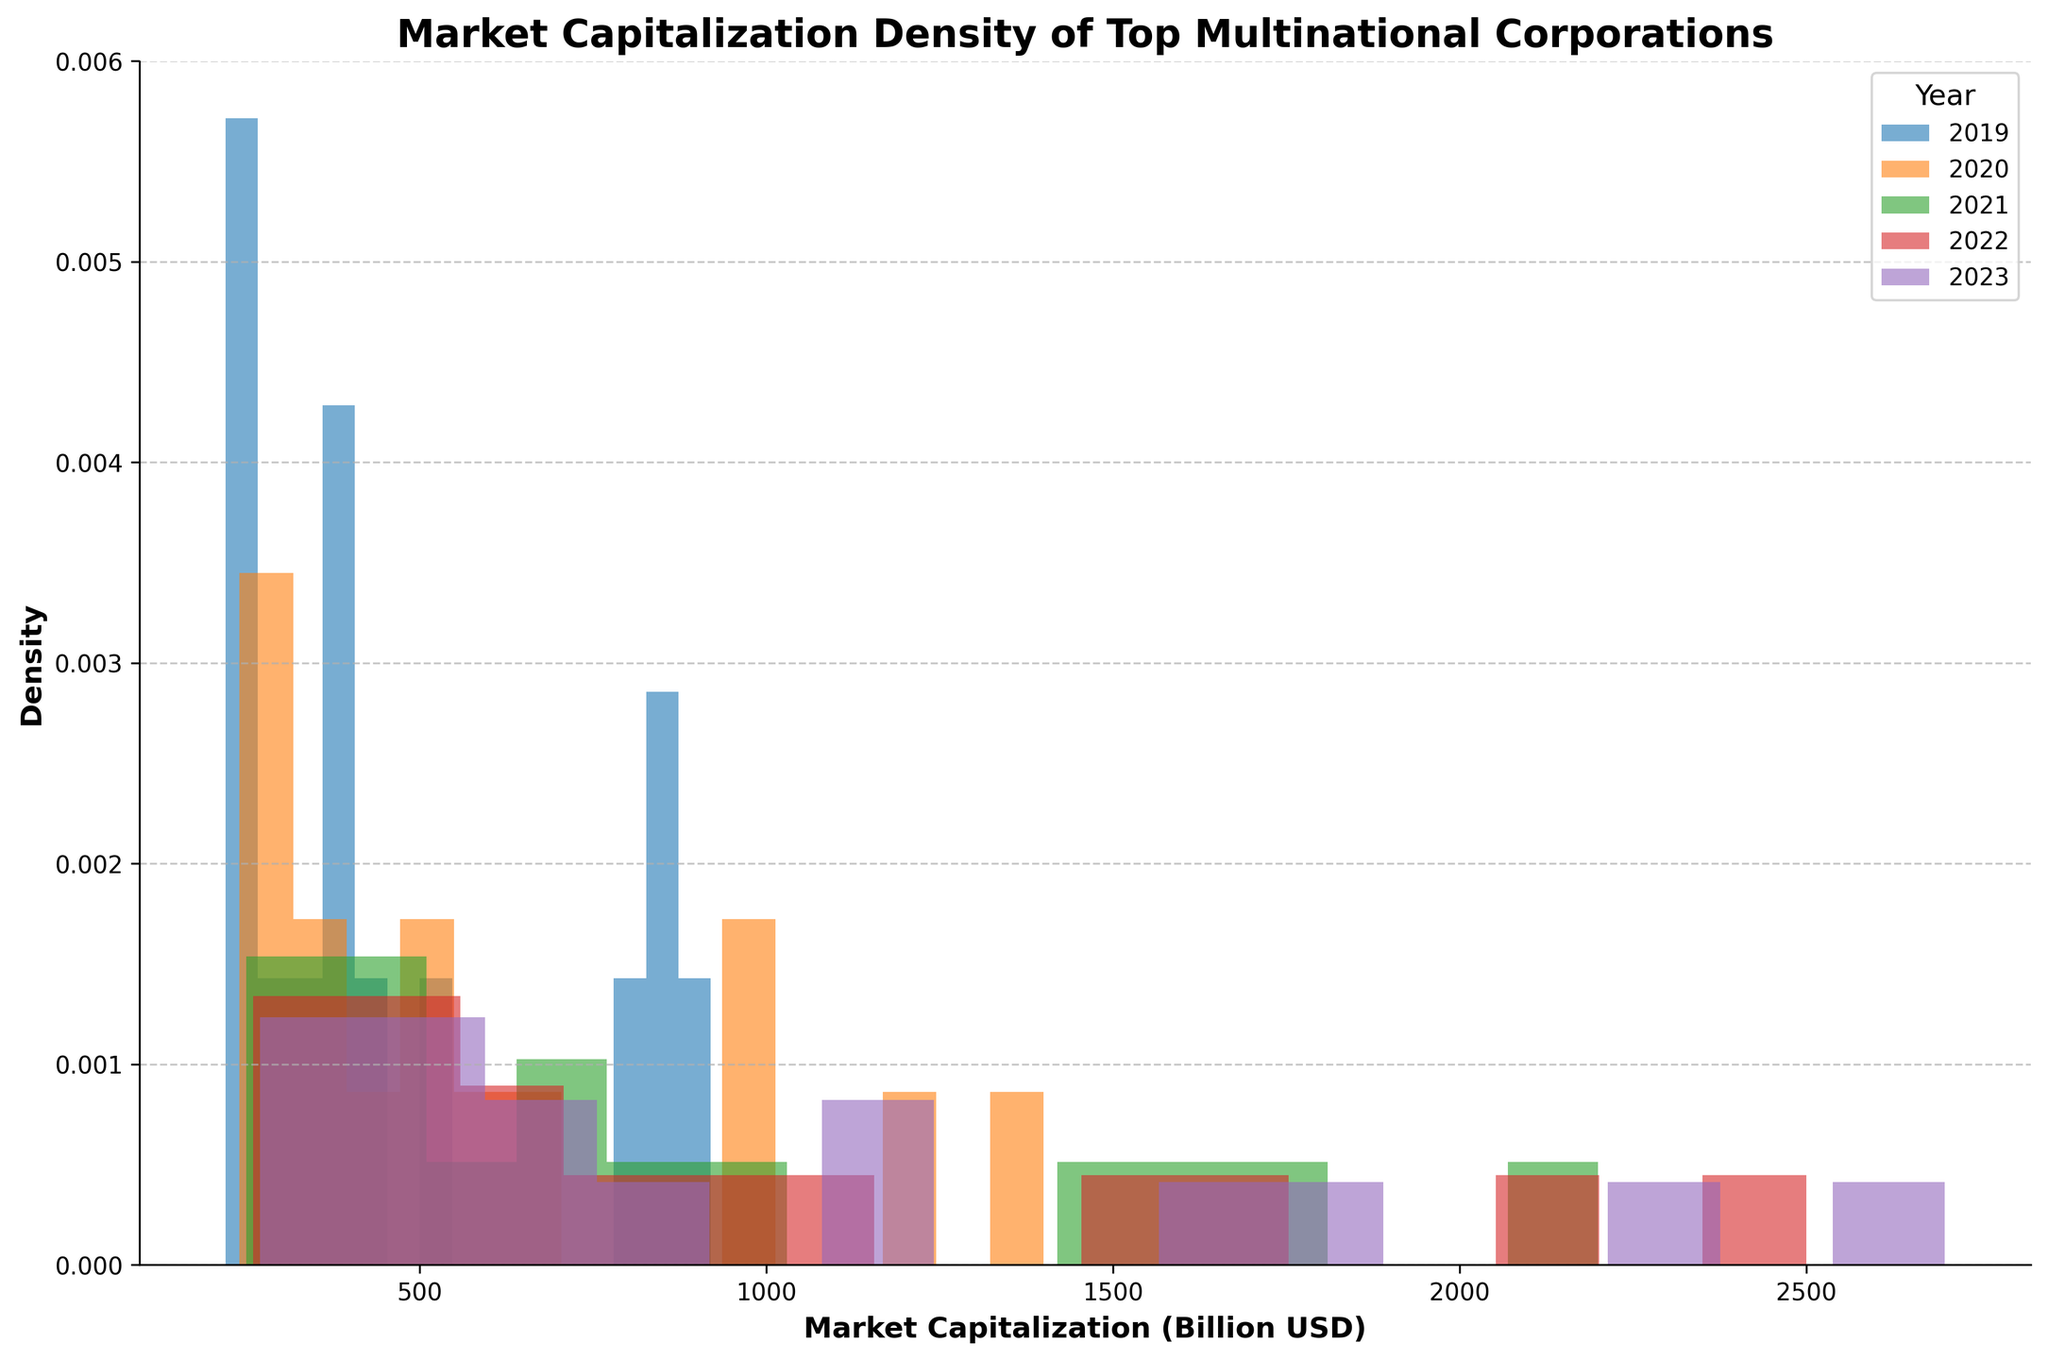What's the title of the figure? The title is displayed at the top of the figure.
Answer: Market Capitalization Density of Top Multinational Corporations What does the x-axis on the plot represent? The x-axis label indicates the variable it represents.
Answer: Market Capitalization (Billion USD) What is the y-axis measuring in the plot? The y-axis label indicates the variable it represents.
Answer: Density Which year has the highest density peak? By observing the highest peak among the density curves, the year with the highest peak can be identified by its color.
Answer: 2021 Which color represents the year 2020 in the density plot? The legend specifies the color corresponding to each year.
Answer: Orange How does the market capitalization distribution in 2019 compare to that in 2023? Comparing the density peaks and spread for 2019 and 2023 helps to see if distributions are similar or different. The 2019 curve is more spread out and lower in peak, indicating more variance and lower density in higher market caps. The 2023 curve shows more concentration around higher market caps.
Answer: 2023 has higher market caps and a more concentrated distribution What is the approximate market capitalization range where most companies fell in 2023? Observing the regions where the density line is highest for 2023, the most probable market cap range can be inferred.
Answer: 2400-2700 Billion USD In which year did the density plot show the widest spread of market capitalizations? The widest spread indicates higher variance; it can be inferred by observing the year with the broadest and flattest curve.
Answer: 2019 Did the market capitalization densities tend to move towards higher or lower values from 2019 to 2023? Observing the shift in the density peaks from the left (lower values) to the right (higher values) across years suggests the direction of movement.
Answer: Higher values What trend in market capitalization over the years can be observed for major corporations? By observing the general shift of density peaks from left to right over the years, we can infer the trend in market capitalization.
Answer: Increasing trend What does the peak of the 2022 density line suggest about market capitalizations that year? The height of the peak indicates the higher concentration of market capitalizations around a specific value in 2022.
Answer: There was a high concentration around 2100-2500 Billion USD 